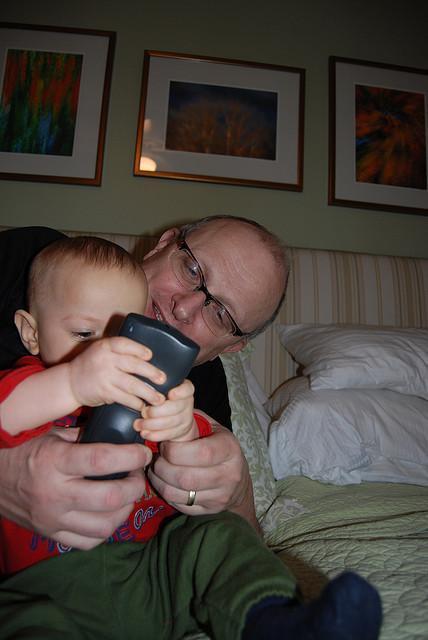What is the baby playing with?
Choose the correct response, then elucidate: 'Answer: answer
Rationale: rationale.'
Options: Cellphone, remote control, calculator, toy. Answer: remote control.
Rationale: This looks like the back of many tv remotes. 